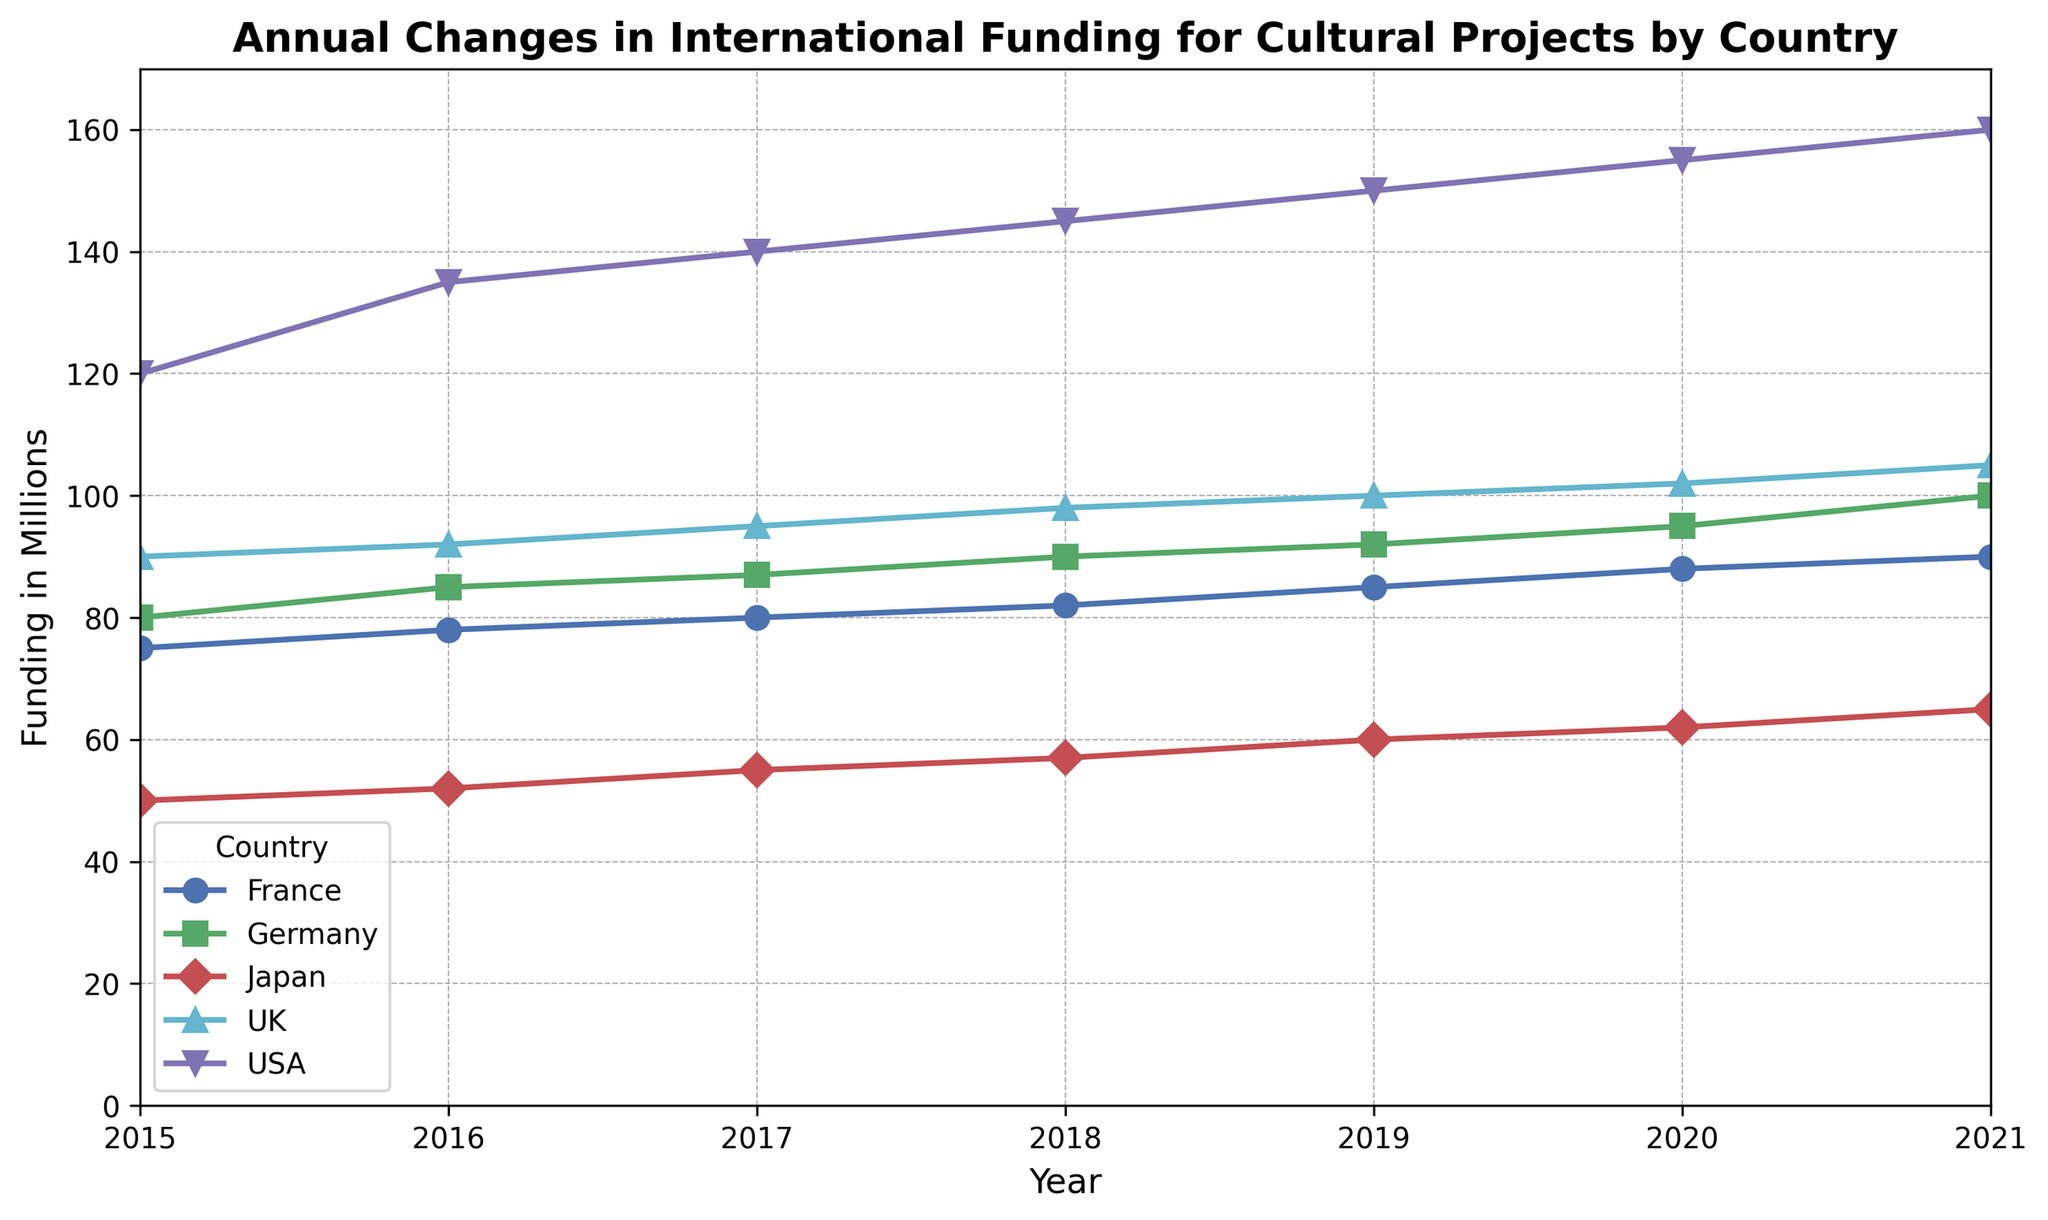How has the funding for cultural projects by the USA changed from 2015 to 2021? From the line representing the USA, the funding in 2015 was 120 million and increased every year, reaching 160 million in 2021. The change can be visually observed as an upward trend.
Answer: The funding increased from 120 million in 2015 to 160 million in 2021 Which country had the largest increase in funding between 2015 and 2021? The USA's funding increased from 120 million to 160 million (an increase of 40 million), the UK from 90 million to 105 million (an increase of 15 million), Germany from 80 million to 100 million (an increase of 20 million), France from 75 million to 90 million (an increase of 15 million), and Japan from 50 million to 65 million (an increase of 15 million). Thus, the USA had the largest increase.
Answer: USA Compare the funding levels of Germany and France in 2018. Which country had higher funding, and by how much? In 2018, Germany's funding was 90 million and France's funding was 82 million. Germany had higher funding by 90 million - 82 million = 8 million.
Answer: Germany by 8 million Has the funding for cultural projects in Japan shown a consistent trend over the years? Observing Japan's line, the funding consistently increases each year from 50 million in 2015 to 65 million in 2021. The trend is steadily upward.
Answer: Yes What was the total funding for cultural projects across all the countries in 2020? In 2020, the funding amounts were USA: 155 million, UK: 102 million, Germany: 95 million, France: 88 million, Japan: 62 million. Summing these up: 155 + 102 + 95 + 88 + 62 = 502 million.
Answer: 502 million Between 2015 and 2021, which country's funding exhibited the most stable trend, and what indicates this stability? A stable trend would be a consistent or little change in funding amounts. The UK's funding is relatively stable, starting from 90 million in 2015 and gradually increasing to 105 million in 2021, with no sharp fluctuations.
Answer: UK In which year did France and Japan have equal funding levels, and what was the funding amount that year? Observing the lines, both France and Japan had equal funding in 2019, with both being at 85 million.
Answer: In 2019, 85 million Looking at the visual differences, which country had the steepest rise in funding in any single year? The steepest rise would be indicated by the steepest slope in the plot. The USA had a noticeable increase from 2015 to 2016, rising from 120 million to 135 million, a 15 million increase in one year.
Answer: USA from 2015 to 2016 Was there any year in which all the countries experienced an increase in funding compared to the previous year? Observing the plot lines, it can be seen that in each year, each country has shown an increased amount compared to the previous year.
Answer: Yes, every year 